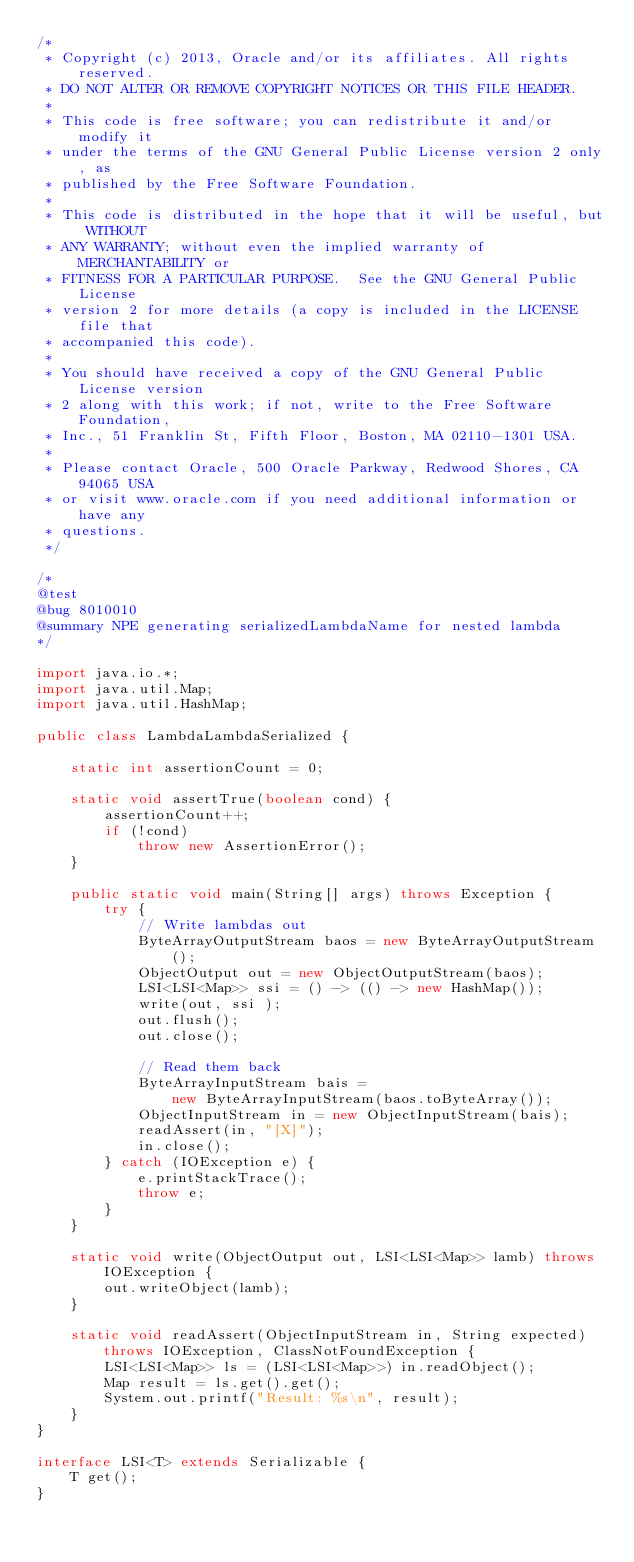Convert code to text. <code><loc_0><loc_0><loc_500><loc_500><_Java_>/*
 * Copyright (c) 2013, Oracle and/or its affiliates. All rights reserved.
 * DO NOT ALTER OR REMOVE COPYRIGHT NOTICES OR THIS FILE HEADER.
 *
 * This code is free software; you can redistribute it and/or modify it
 * under the terms of the GNU General Public License version 2 only, as
 * published by the Free Software Foundation.
 *
 * This code is distributed in the hope that it will be useful, but WITHOUT
 * ANY WARRANTY; without even the implied warranty of MERCHANTABILITY or
 * FITNESS FOR A PARTICULAR PURPOSE.  See the GNU General Public License
 * version 2 for more details (a copy is included in the LICENSE file that
 * accompanied this code).
 *
 * You should have received a copy of the GNU General Public License version
 * 2 along with this work; if not, write to the Free Software Foundation,
 * Inc., 51 Franklin St, Fifth Floor, Boston, MA 02110-1301 USA.
 *
 * Please contact Oracle, 500 Oracle Parkway, Redwood Shores, CA 94065 USA
 * or visit www.oracle.com if you need additional information or have any
 * questions.
 */

/*
@test
@bug 8010010
@summary NPE generating serializedLambdaName for nested lambda
*/

import java.io.*;
import java.util.Map;
import java.util.HashMap;

public class LambdaLambdaSerialized {

    static int assertionCount = 0;

    static void assertTrue(boolean cond) {
        assertionCount++;
        if (!cond)
            throw new AssertionError();
    }

    public static void main(String[] args) throws Exception {
        try {
            // Write lambdas out
            ByteArrayOutputStream baos = new ByteArrayOutputStream();
            ObjectOutput out = new ObjectOutputStream(baos);
            LSI<LSI<Map>> ssi = () -> (() -> new HashMap());
            write(out, ssi );
            out.flush();
            out.close();

            // Read them back
            ByteArrayInputStream bais =
                new ByteArrayInputStream(baos.toByteArray());
            ObjectInputStream in = new ObjectInputStream(bais);
            readAssert(in, "[X]");
            in.close();
        } catch (IOException e) {
            e.printStackTrace();
            throw e;
        }
    }

    static void write(ObjectOutput out, LSI<LSI<Map>> lamb) throws IOException {
        out.writeObject(lamb);
    }

    static void readAssert(ObjectInputStream in, String expected)  throws IOException, ClassNotFoundException {
        LSI<LSI<Map>> ls = (LSI<LSI<Map>>) in.readObject();
        Map result = ls.get().get();
        System.out.printf("Result: %s\n", result);
    }
}

interface LSI<T> extends Serializable {
    T get();
}
</code> 